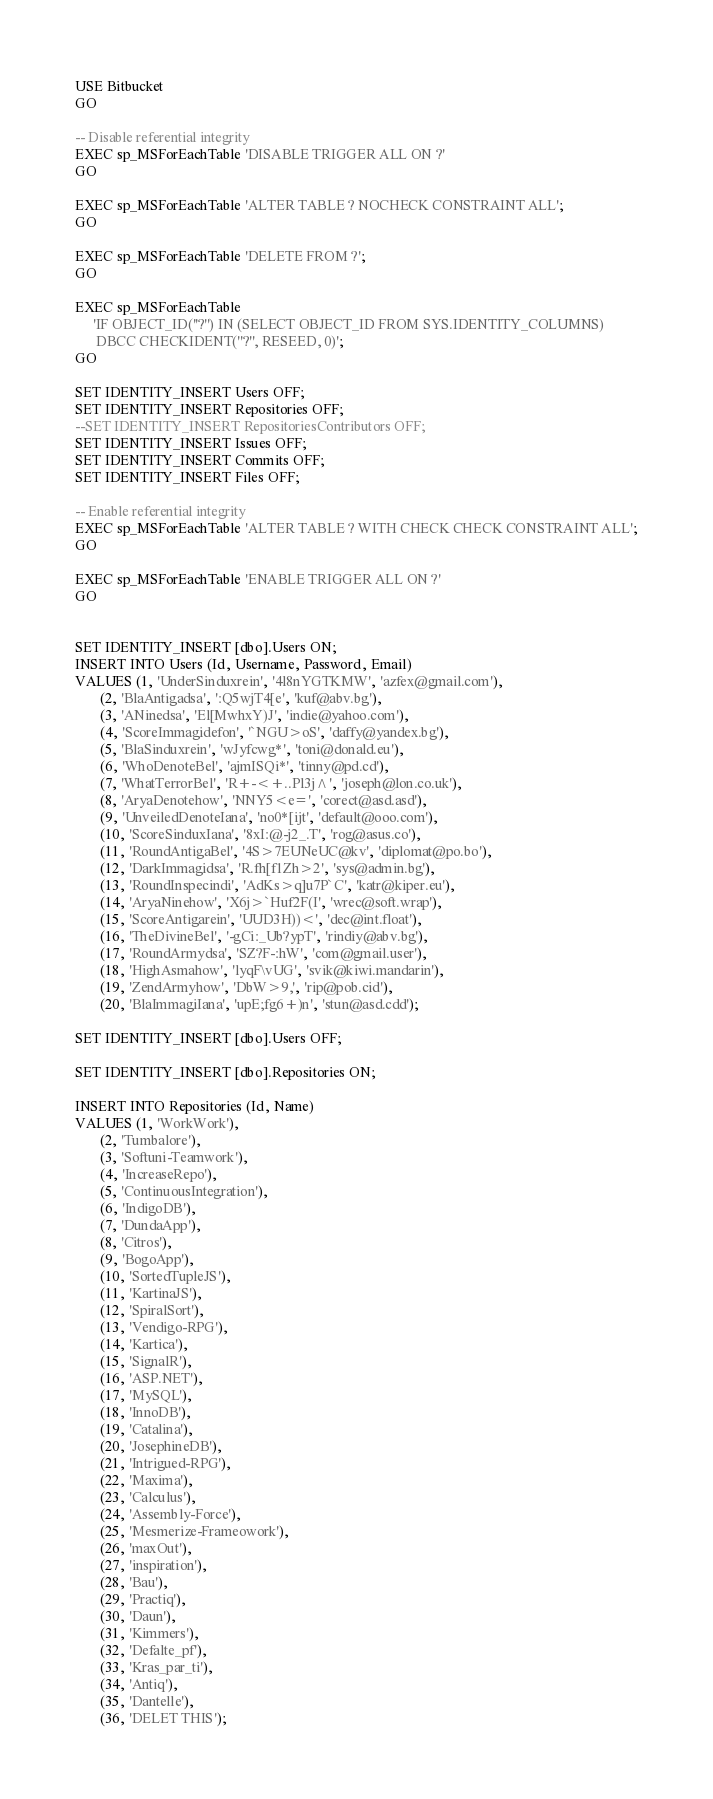Convert code to text. <code><loc_0><loc_0><loc_500><loc_500><_SQL_>USE Bitbucket
GO

-- Disable referential integrity
EXEC sp_MSForEachTable 'DISABLE TRIGGER ALL ON ?'
GO

EXEC sp_MSForEachTable 'ALTER TABLE ? NOCHECK CONSTRAINT ALL';
GO

EXEC sp_MSForEachTable 'DELETE FROM ?';
GO

EXEC sp_MSForEachTable
     'IF OBJECT_ID(''?'') IN (SELECT OBJECT_ID FROM SYS.IDENTITY_COLUMNS)
      DBCC CHECKIDENT(''?'', RESEED, 0)';
GO

SET IDENTITY_INSERT Users OFF;
SET IDENTITY_INSERT Repositories OFF;
--SET IDENTITY_INSERT RepositoriesContributors OFF;
SET IDENTITY_INSERT Issues OFF;
SET IDENTITY_INSERT Commits OFF;
SET IDENTITY_INSERT Files OFF;

-- Enable referential integrity
EXEC sp_MSForEachTable 'ALTER TABLE ? WITH CHECK CHECK CONSTRAINT ALL';
GO

EXEC sp_MSForEachTable 'ENABLE TRIGGER ALL ON ?'
GO


SET IDENTITY_INSERT [dbo].Users ON;
INSERT INTO Users (Id, Username, Password, Email)
VALUES (1, 'UnderSinduxrein', '4l8nYGTKMW', 'azfex@gmail.com'),
       (2, 'BlaAntigadsa', ':Q5wjT4[e', 'kuf@abv.bg'),
       (3, 'ANinedsa', 'El[MwhxY)J', 'indie@yahoo.com'),
       (4, 'ScoreImmagidefon', '`NGU>oS', 'daffy@yandex.bg'),
       (5, 'BlaSinduxrein', 'wJyfcwg*', 'toni@donald.eu'),
       (6, 'WhoDenoteBel', 'ajmISQi*', 'tinny@pd.cd'),
       (7, 'WhatTerrorBel', 'R+-<+..Pl3j^', 'joseph@lon.co.uk'),
       (8, 'AryaDenotehow', 'NNY5<e=', 'corect@asd.asd'),
       (9, 'UnveiledDenoteIana', 'no0*[ijt', 'default@ooo.com'),
       (10, 'ScoreSinduxIana', '8xI:@-j2_.T', 'rog@asus.co'),
       (11, 'RoundAntigaBel', '4S>7EUNeUC@kv', 'diplomat@po.bo'),
       (12, 'DarkImmagidsa', 'R.fh[f1Zh>2', 'sys@admin.bg'),
       (13, 'RoundInspecindi', 'AdKs>q]u7P`C', 'katr@kiper.eu'),
       (14, 'AryaNinehow', 'X6j>`Huf2F(I', 'wrec@soft.wrap'),
       (15, 'ScoreAntigarein', 'UUD3H))<', 'dec@int.float'),
       (16, 'TheDivineBel', '-gCi:_Ub?ypT', 'rindiy@abv.bg'),
       (17, 'RoundArmydsa', 'SZ?F-:hW', 'com@gmail.user'),
       (18, 'HighAsmahow', 'lyqF\vUG', 'svik@kiwi.mandarin'),
       (19, 'ZendArmyhow', 'DbW>9,', 'rip@pob.cid'),
       (20, 'BlaImmagiIana', 'upE;fg6+)n', 'stun@asd.cdd');

SET IDENTITY_INSERT [dbo].Users OFF;

SET IDENTITY_INSERT [dbo].Repositories ON;

INSERT INTO Repositories (Id, Name)
VALUES (1, 'WorkWork'),
       (2, 'Tumbalore'),
       (3, 'Softuni-Teamwork'),
       (4, 'IncreaseRepo'),
       (5, 'ContinuousIntegration'),
       (6, 'IndigoDB'),
       (7, 'DundaApp'),
       (8, 'Citros'),
       (9, 'BogoApp'),
       (10, 'SortedTupleJS'),
       (11, 'KartinaJS'),
       (12, 'SpiralSort'),
       (13, 'Vendigo-RPG'),
       (14, 'Kartica'),
       (15, 'SignalR'),
       (16, 'ASP.NET'),
       (17, 'MySQL'),
       (18, 'InnoDB'),
       (19, 'Catalina'),
       (20, 'JosephineDB'),
       (21, 'Intrigued-RPG'),
       (22, 'Maxima'),
       (23, 'Calculus'),
       (24, 'Assembly-Force'),
       (25, 'Mesmerize-Frameowork'),
       (26, 'maxOut'),
       (27, 'inspiration'),
       (28, 'Bau'),
       (29, 'Practiq'),
       (30, 'Daun'),
       (31, 'Kimmers'),
       (32, 'Defalte_pf'),
       (33, 'Kras_par_ti'),
       (34, 'Antiq'),
       (35, 'Dantelle'),
       (36, 'DELET THIS');
</code> 